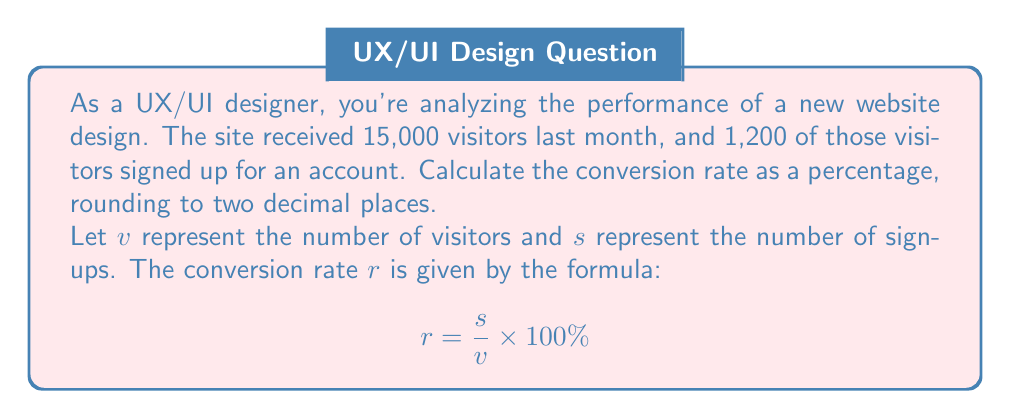Solve this math problem. To solve this problem, we'll follow these steps:

1. Identify the given values:
   $v$ (visitors) = 15,000
   $s$ (sign-ups) = 1,200

2. Substitute these values into the conversion rate formula:

   $$ r = \frac{s}{v} \times 100\% $$
   $$ r = \frac{1,200}{15,000} \times 100\% $$

3. Simplify the fraction:
   $$ r = \frac{1,200}{15,000} = \frac{4}{50} = 0.08 $$

4. Multiply by 100% to convert to a percentage:
   $$ r = 0.08 \times 100\% = 8\% $$

5. The question asks to round to two decimal places, but our result is already in that format.

Therefore, the conversion rate from website visitors to sign-ups is 8.00%.
Answer: 8.00% 